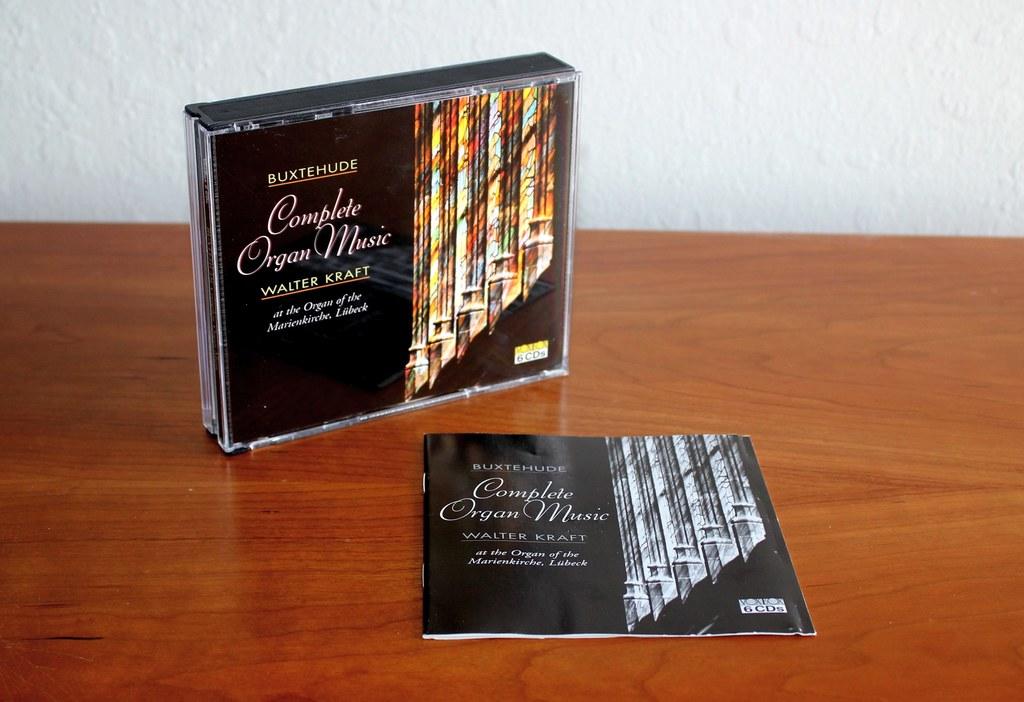What type of music is on the cd?
Give a very brief answer. Organ. What musician is listed on these cds?
Keep it short and to the point. Walter kraft. 